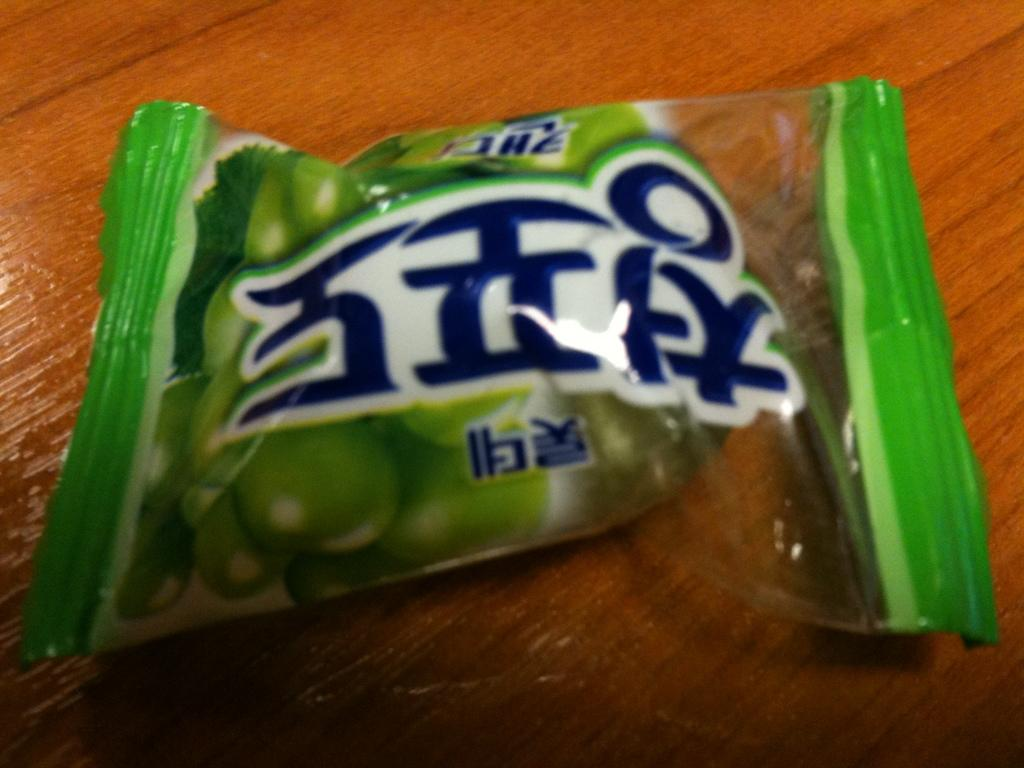Provide a one-sentence caption for the provided image. A green packet of items that has foreign text on it. 